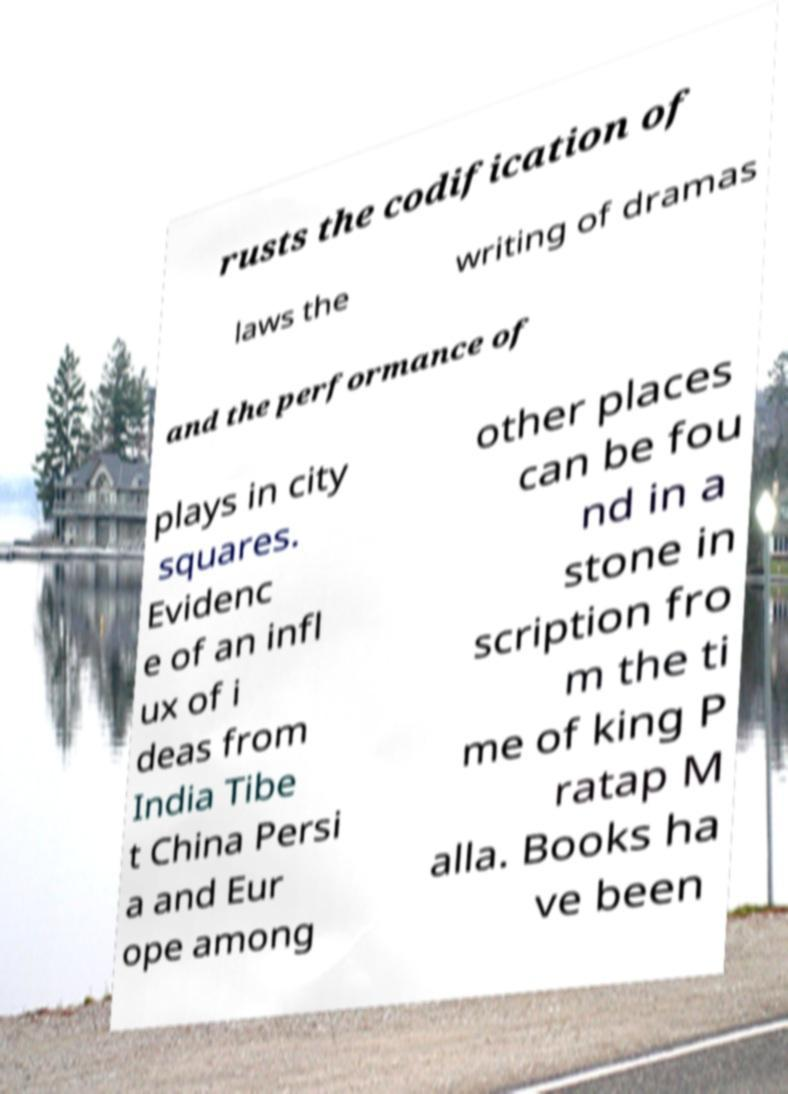There's text embedded in this image that I need extracted. Can you transcribe it verbatim? rusts the codification of laws the writing of dramas and the performance of plays in city squares. Evidenc e of an infl ux of i deas from India Tibe t China Persi a and Eur ope among other places can be fou nd in a stone in scription fro m the ti me of king P ratap M alla. Books ha ve been 